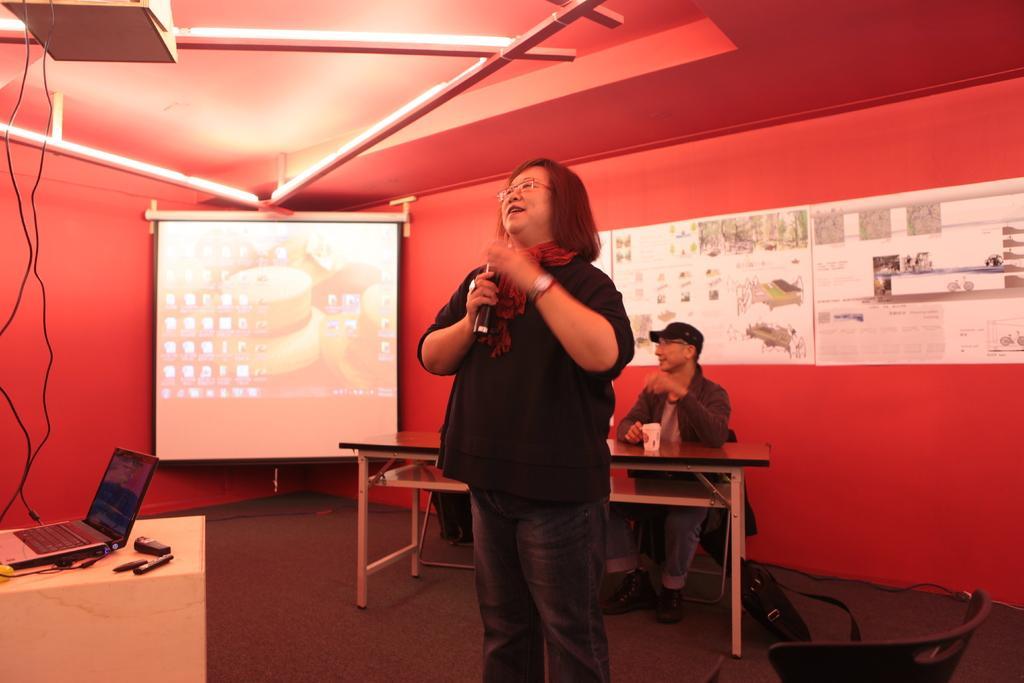Can you describe this image briefly? There is a woman standing in a room holding a microphone in her hands. Behind her there is a man sitting on a bench. There is a led projector screen. We can observe a laptop here on the table. In the background there is a wall in red color. 